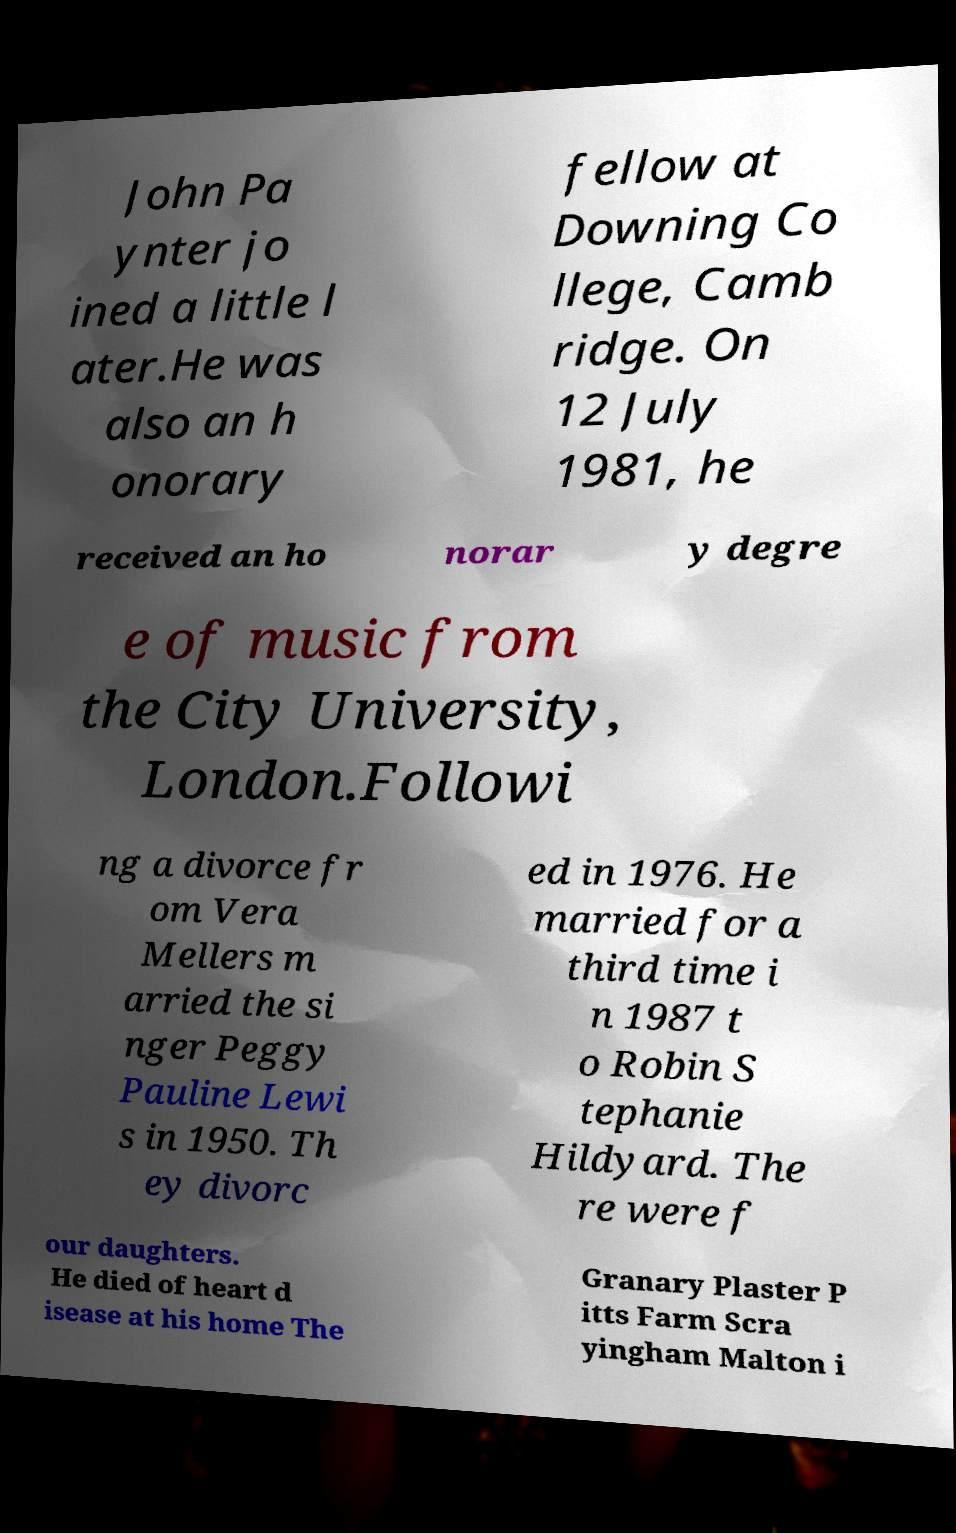There's text embedded in this image that I need extracted. Can you transcribe it verbatim? John Pa ynter jo ined a little l ater.He was also an h onorary fellow at Downing Co llege, Camb ridge. On 12 July 1981, he received an ho norar y degre e of music from the City University, London.Followi ng a divorce fr om Vera Mellers m arried the si nger Peggy Pauline Lewi s in 1950. Th ey divorc ed in 1976. He married for a third time i n 1987 t o Robin S tephanie Hildyard. The re were f our daughters. He died of heart d isease at his home The Granary Plaster P itts Farm Scra yingham Malton i 